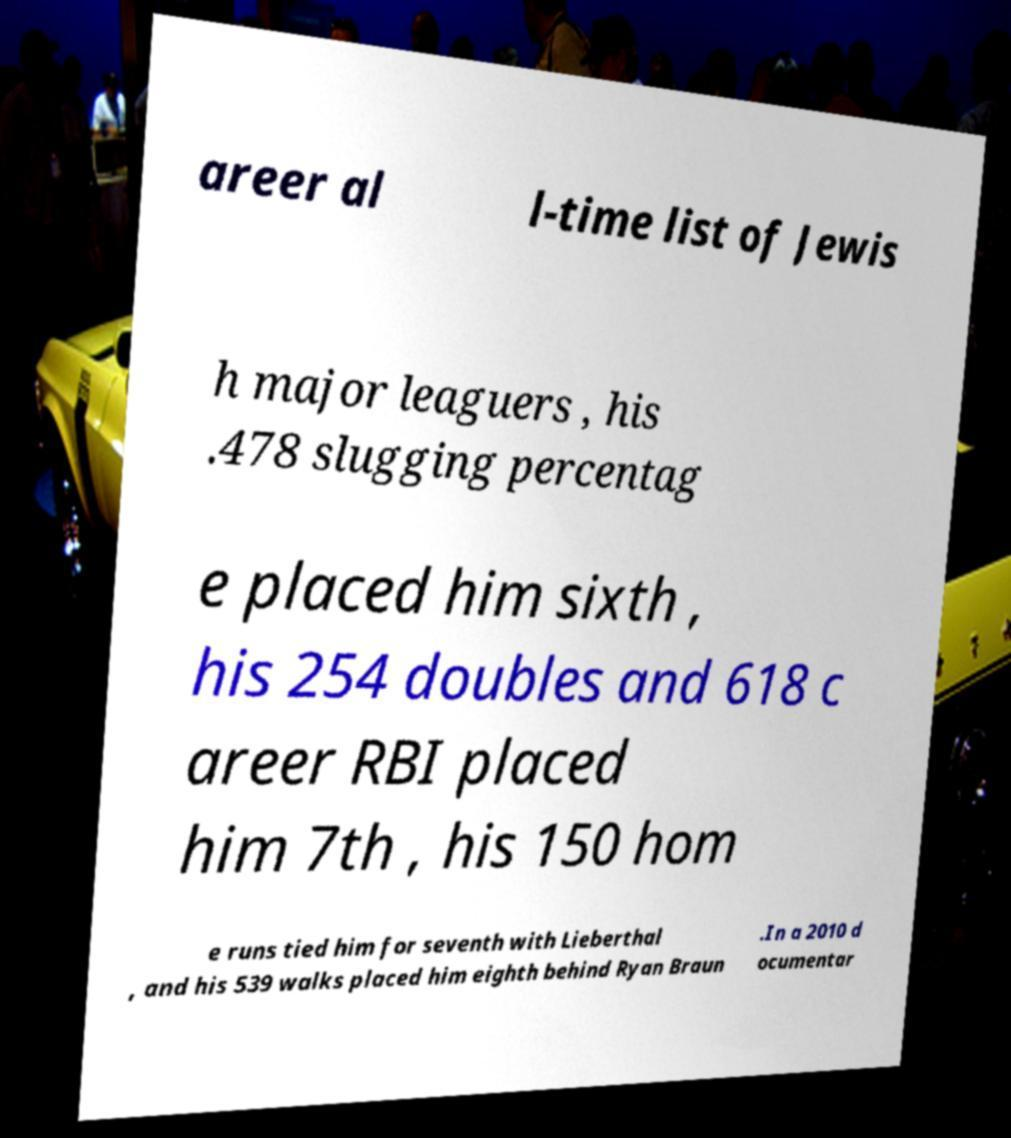I need the written content from this picture converted into text. Can you do that? areer al l-time list of Jewis h major leaguers , his .478 slugging percentag e placed him sixth , his 254 doubles and 618 c areer RBI placed him 7th , his 150 hom e runs tied him for seventh with Lieberthal , and his 539 walks placed him eighth behind Ryan Braun .In a 2010 d ocumentar 